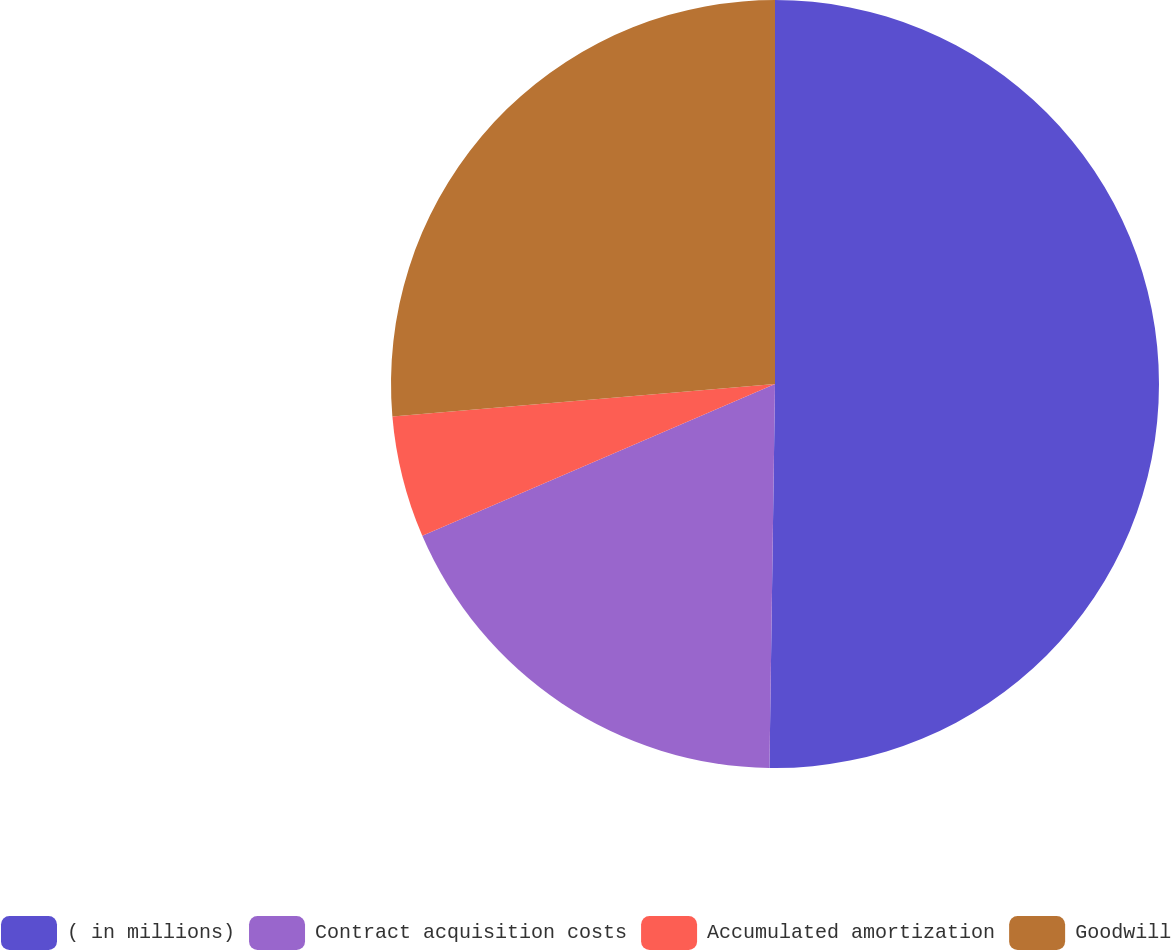Convert chart. <chart><loc_0><loc_0><loc_500><loc_500><pie_chart><fcel>( in millions)<fcel>Contract acquisition costs<fcel>Accumulated amortization<fcel>Goodwill<nl><fcel>50.23%<fcel>18.3%<fcel>5.12%<fcel>26.35%<nl></chart> 